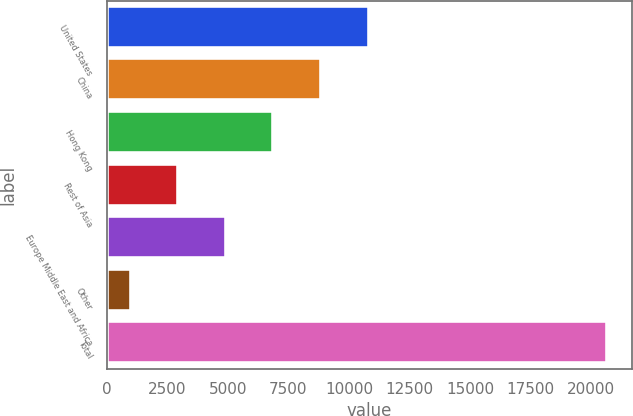<chart> <loc_0><loc_0><loc_500><loc_500><bar_chart><fcel>United States<fcel>China<fcel>Hong Kong<fcel>Rest of Asia<fcel>Europe Middle East and Africa<fcel>Other<fcel>Total<nl><fcel>10814.5<fcel>8848<fcel>6881.5<fcel>2948.5<fcel>4915<fcel>982<fcel>20647<nl></chart> 